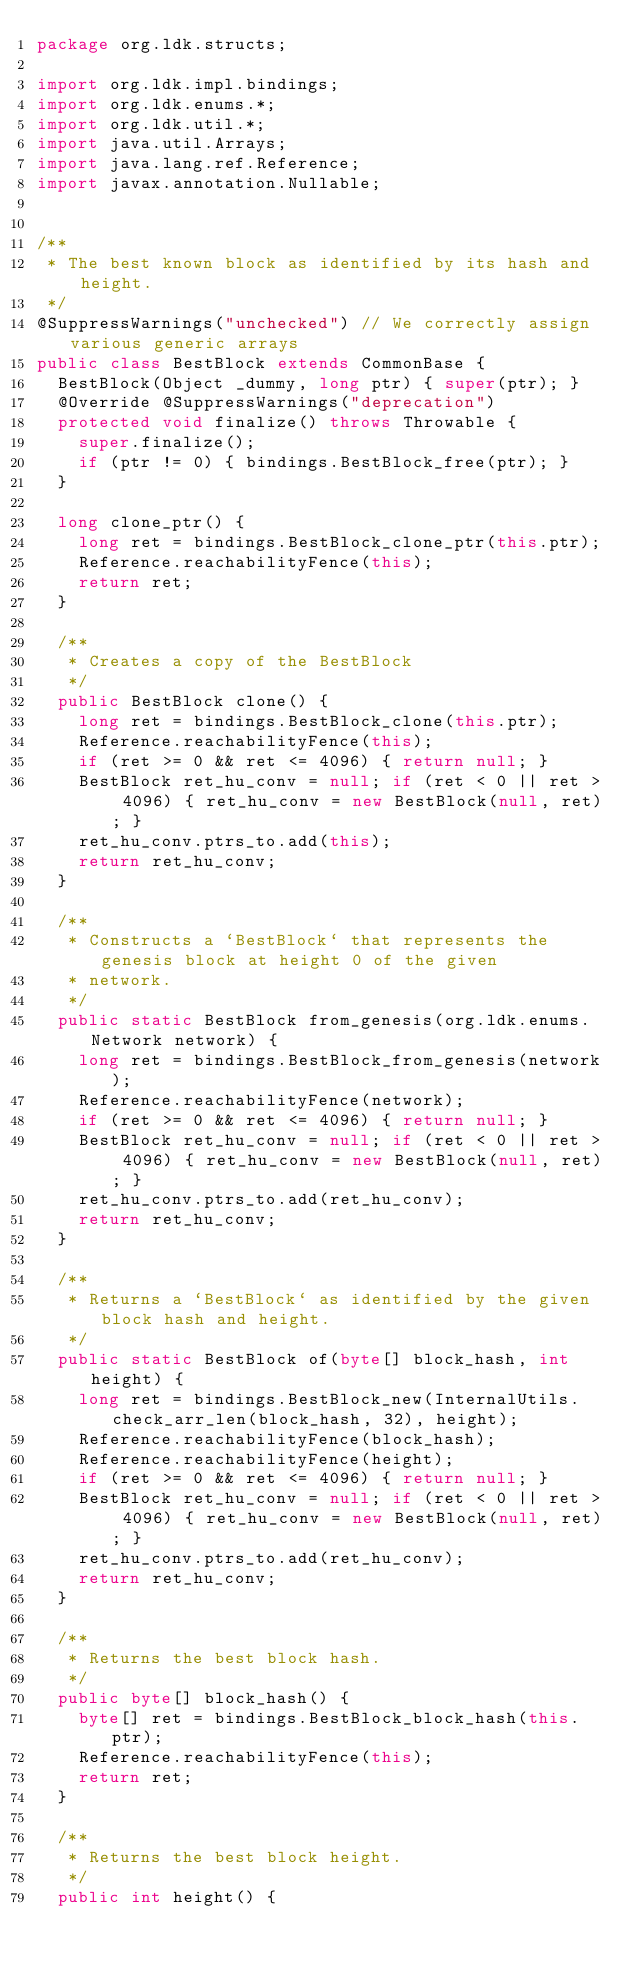Convert code to text. <code><loc_0><loc_0><loc_500><loc_500><_Java_>package org.ldk.structs;

import org.ldk.impl.bindings;
import org.ldk.enums.*;
import org.ldk.util.*;
import java.util.Arrays;
import java.lang.ref.Reference;
import javax.annotation.Nullable;


/**
 * The best known block as identified by its hash and height.
 */
@SuppressWarnings("unchecked") // We correctly assign various generic arrays
public class BestBlock extends CommonBase {
	BestBlock(Object _dummy, long ptr) { super(ptr); }
	@Override @SuppressWarnings("deprecation")
	protected void finalize() throws Throwable {
		super.finalize();
		if (ptr != 0) { bindings.BestBlock_free(ptr); }
	}

	long clone_ptr() {
		long ret = bindings.BestBlock_clone_ptr(this.ptr);
		Reference.reachabilityFence(this);
		return ret;
	}

	/**
	 * Creates a copy of the BestBlock
	 */
	public BestBlock clone() {
		long ret = bindings.BestBlock_clone(this.ptr);
		Reference.reachabilityFence(this);
		if (ret >= 0 && ret <= 4096) { return null; }
		BestBlock ret_hu_conv = null; if (ret < 0 || ret > 4096) { ret_hu_conv = new BestBlock(null, ret); }
		ret_hu_conv.ptrs_to.add(this);
		return ret_hu_conv;
	}

	/**
	 * Constructs a `BestBlock` that represents the genesis block at height 0 of the given
	 * network.
	 */
	public static BestBlock from_genesis(org.ldk.enums.Network network) {
		long ret = bindings.BestBlock_from_genesis(network);
		Reference.reachabilityFence(network);
		if (ret >= 0 && ret <= 4096) { return null; }
		BestBlock ret_hu_conv = null; if (ret < 0 || ret > 4096) { ret_hu_conv = new BestBlock(null, ret); }
		ret_hu_conv.ptrs_to.add(ret_hu_conv);
		return ret_hu_conv;
	}

	/**
	 * Returns a `BestBlock` as identified by the given block hash and height.
	 */
	public static BestBlock of(byte[] block_hash, int height) {
		long ret = bindings.BestBlock_new(InternalUtils.check_arr_len(block_hash, 32), height);
		Reference.reachabilityFence(block_hash);
		Reference.reachabilityFence(height);
		if (ret >= 0 && ret <= 4096) { return null; }
		BestBlock ret_hu_conv = null; if (ret < 0 || ret > 4096) { ret_hu_conv = new BestBlock(null, ret); }
		ret_hu_conv.ptrs_to.add(ret_hu_conv);
		return ret_hu_conv;
	}

	/**
	 * Returns the best block hash.
	 */
	public byte[] block_hash() {
		byte[] ret = bindings.BestBlock_block_hash(this.ptr);
		Reference.reachabilityFence(this);
		return ret;
	}

	/**
	 * Returns the best block height.
	 */
	public int height() {</code> 